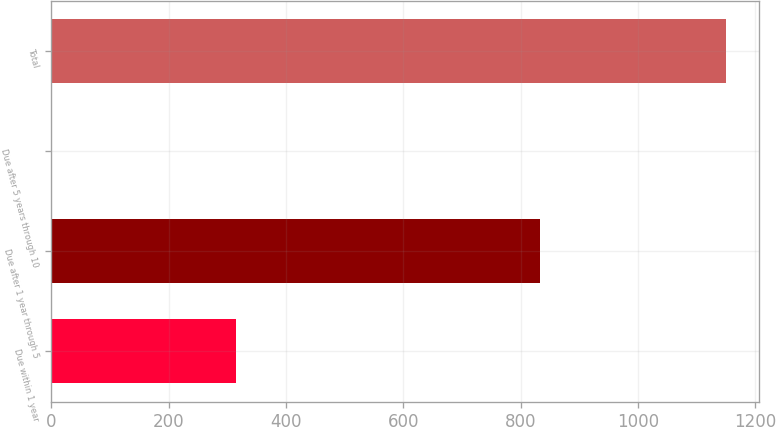Convert chart to OTSL. <chart><loc_0><loc_0><loc_500><loc_500><bar_chart><fcel>Due within 1 year<fcel>Due after 1 year through 5<fcel>Due after 5 years through 10<fcel>Total<nl><fcel>314<fcel>833<fcel>1<fcel>1149<nl></chart> 